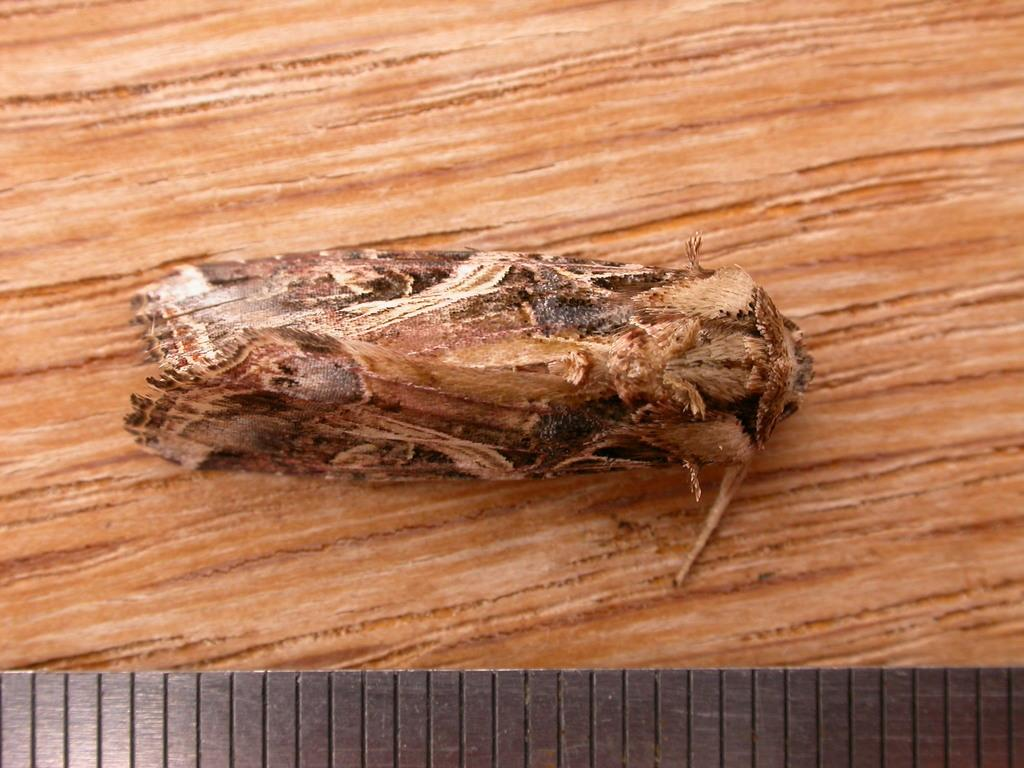What type of creature is in the image? There is an insect in the image. What surface is the insect on? The insect is on a wooden surface. What material is present at the bottom of the image? There is steel metal at the bottom of the image. Is the spy using the insect to transmit secret information in the image? There is no spy or secret information present in the image; it only features an insect on a wooden surface and steel metal at the bottom. 